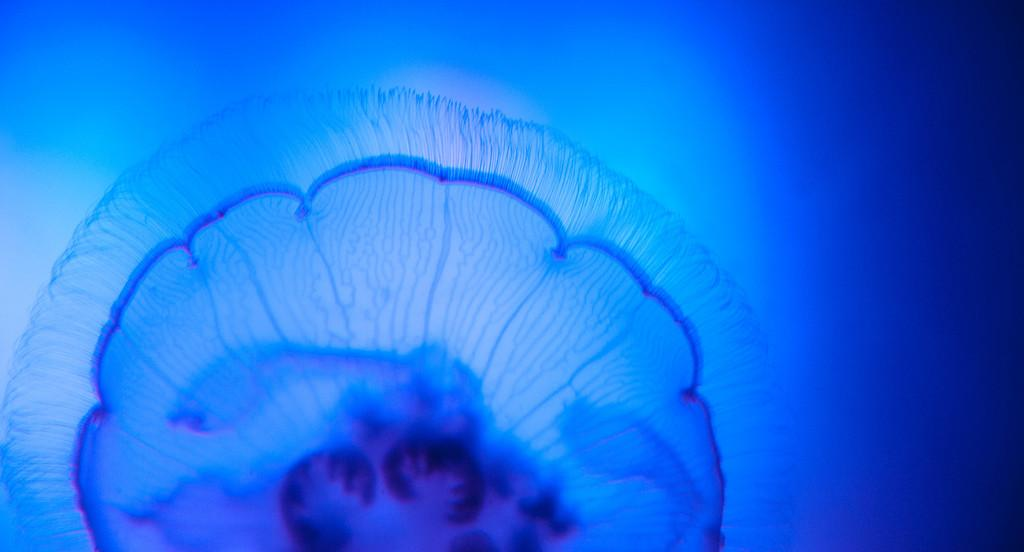What type of animal is in the image? There is a jellyfish in the image. Where is the jellyfish located? The jellyfish is in the water. What type of quartz can be seen in the image? There is no quartz present in the image; it features a jellyfish in the water. What is the jellyfish writing in the image? Jellyfish do not have the ability to write, and there is no writing present in the image. 